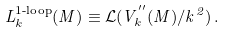Convert formula to latex. <formula><loc_0><loc_0><loc_500><loc_500>L _ { k } ^ { \text {1-loop} } ( M ) \equiv \mathcal { L } ( V _ { k } ^ { ^ { \prime \prime } } ( M ) / k ^ { 2 } ) \, .</formula> 